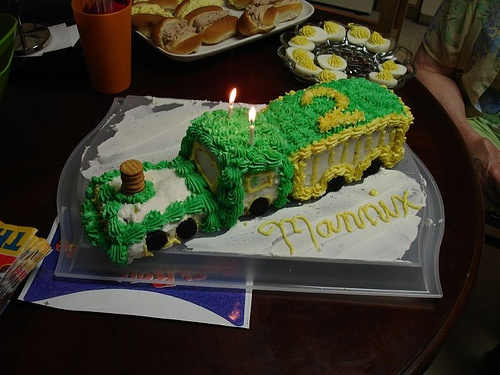Describe the objects in this image and their specific colors. I can see dining table in black, darkgray, gray, and darkgreen tones, cake in black, darkgreen, olive, and green tones, people in black, gray, and maroon tones, cup in black, maroon, brown, and gray tones, and sandwich in black, maroon, and olive tones in this image. 